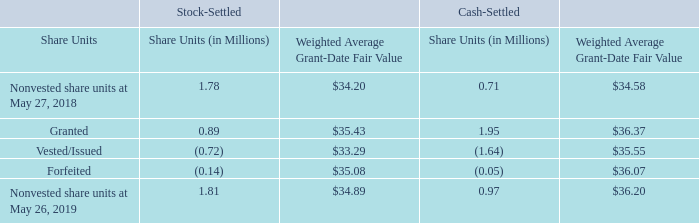Share Unit Awards
In accordance with stockholder-approved equity incentive plans, we grant awards of restricted stock units and cash-settled restricted stock units ("share units") to employees and directors. These awards generally have requisite service periods of three years. Under each such award, stock or cash (as applicable) is issued without direct cost to the employee. We estimate the fair value of the share units based upon the market price of our stock at the date of grant. Certain share unit grants do not provide for the payment of dividend equivalents to the participant during the requisite service period (the "vesting period"). For those grants, the value of the grants is reduced by the net present value of the foregone dividend equivalent payments.
We recognize compensation expense for share unit awards on a straight-line basis over the requisite service period, accounting for forfeitures as they occur. All cash-settled restricted stock units are marked-to-market and presented within other current and noncurrent liabilities in our Consolidated Balance Sheets. The compensation expense for our stock-settled share unit awards totaled $23.9 million, $21.8 million, and $18.2 million for fiscal 2019, 2018, and 2017, respectively, including discontinued operations of $1.4 million for fiscal 2017. The tax benefit related to the stock-settled share unit award compensation expense for fiscal 2019, 2018, and 2017 was $6.0 million, $7.2 million, and $7.0 million, respectively. The compensation expense for our cash-settled share unit awards totaled $17.5 million, $5.8 million, and $20.9 million for fiscal 2019, 2018, and 2017, respectively, including discontinued operations of $2.6 million for fiscal 2017. The tax benefit related to the cash-settled share unit award compensation expense for fiscal 2019, 2018, and 2017 was $4.4 million, $1.9 million, and $8.0 million, respectively.
During the second quarter of fiscal 2019, in connection with the completion of the Pinnacle acquisition, we granted 2.0 million cash-settled share unit awards at a grant date fair value of $36.37 per share unit to Pinnacle employees in replacement of their unvested restricted share unit awards that were outstanding as of the closing date. Included in the compensation expense described above for fiscal 2019 is expense of $18.9 million for accelerated vesting of awards related to Pinnacle integration restructuring activities, net of the impact of marking-to-market these awards based on a lower market price of shares of Conagra Brands common stock. Approximately $36.3 million of the fair value of the replacement share unit awards granted to Pinnacle employees was attributable to pre-combination service and was included in the purchase price and established as a liability. Included in the expense for cash-settled share unit awards above is income of $6.7 million related to the mark-to-market of this liability. As of May 26, 2019, our liability for the replacement awards was $15.9 million, which includes post-combination service expense, the mark-to-market of the liability, and the impact of payouts since completing the Pinnacle acquisition. Post-combination expense of approximately $3.9 million, based on the market price of shares of Conagra Brands common stock as of May 26, 2019, is expected to be recognized related to the replacement awards over the remaining post-combination service period of approximately two years.
The following table summarizes the nonvested share units as of May 26, 2019 and changes during the fiscal year then ended:
During fiscal 2019, 2018, and 2017, we granted 0.9 million, 0.9 million, and 0.6 million stock-settled share units, respectively, with a weighted average grant date fair value of $35.43, $34.16, and $46.79 per share unit, respectively. During fiscal 2017, we granted 0.4 million cash-settled share units with a weighted average grant date fair value of $48.07 per share unit. No cash-settled share unit awards were granted in fiscal 2018.
The total intrinsic value of stock-settled share units vested was $24.6 million, $18.5 million, and $27.0 million during fiscal 2019, 2018, and 2017, respectively. The total intrinsic value of cash-settled share units vested was $50.5 million, $14.2 million, and $24.0 million during fiscal 2019, 2018, and 2017, respectively.
At May 26, 2019, we had $25.2 million and $4.2 million of total unrecognized compensation expense that will be recognized over a weighted average period of 1.9 years and 1.5 years, related to stock-settled share unit awards and cash-settled share unit awards, respectively
Notes to Consolidated Financial Statements - (Continued) Fiscal Years Ended May 26, 2019, May 27, 2018, and May 28, 2017 (columnar dollars in millions except per share amounts)
Who receives the grant awards of restricted stock units and cash-settled restricted stock units ("share units") according to stockholder-approved equity incentive plans? Employees and directors. How much were the compensation expenses for the company’s stock-settled share unit awards for fiscal 2017, 2018, and 2019, respectively? $18.2 million, $21.8 million, $23.9 million. How much were the total intrinsic values of stock-settled share units during fiscal 2017 and 2018, respectively? $27.0 million, $18.5 million. What is the ratio of the total price of stock-settled nonvested share units to the total intrinsic value of stock-settled share units vested during 2019? (1.81*34.89)/24.6 
Answer: 2.57. What is the total price of nonvested share units?
Answer scale should be: million. (1.81*34.89)+(0.97*36.20) 
Answer: 98.26. What is the average total price of granted share units for either stock-settled or cash-settled, during that year ?
Answer scale should be: million. ((0.89*35.43)+(1.95*36.37))/2 
Answer: 51.23. 